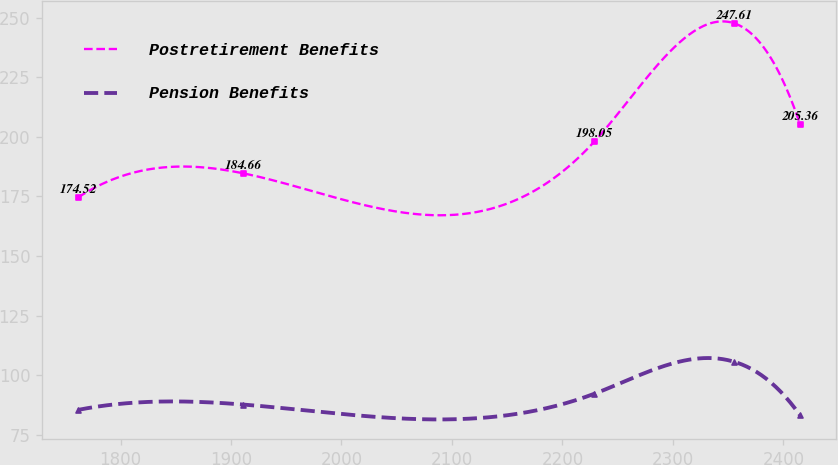Convert chart. <chart><loc_0><loc_0><loc_500><loc_500><line_chart><ecel><fcel>Postretirement Benefits<fcel>Pension Benefits<nl><fcel>1761.51<fcel>174.52<fcel>85.39<nl><fcel>1911<fcel>184.66<fcel>87.64<nl><fcel>2229.02<fcel>198.05<fcel>92.19<nl><fcel>2355.48<fcel>247.61<fcel>105.59<nl><fcel>2415.11<fcel>205.36<fcel>83.14<nl></chart> 